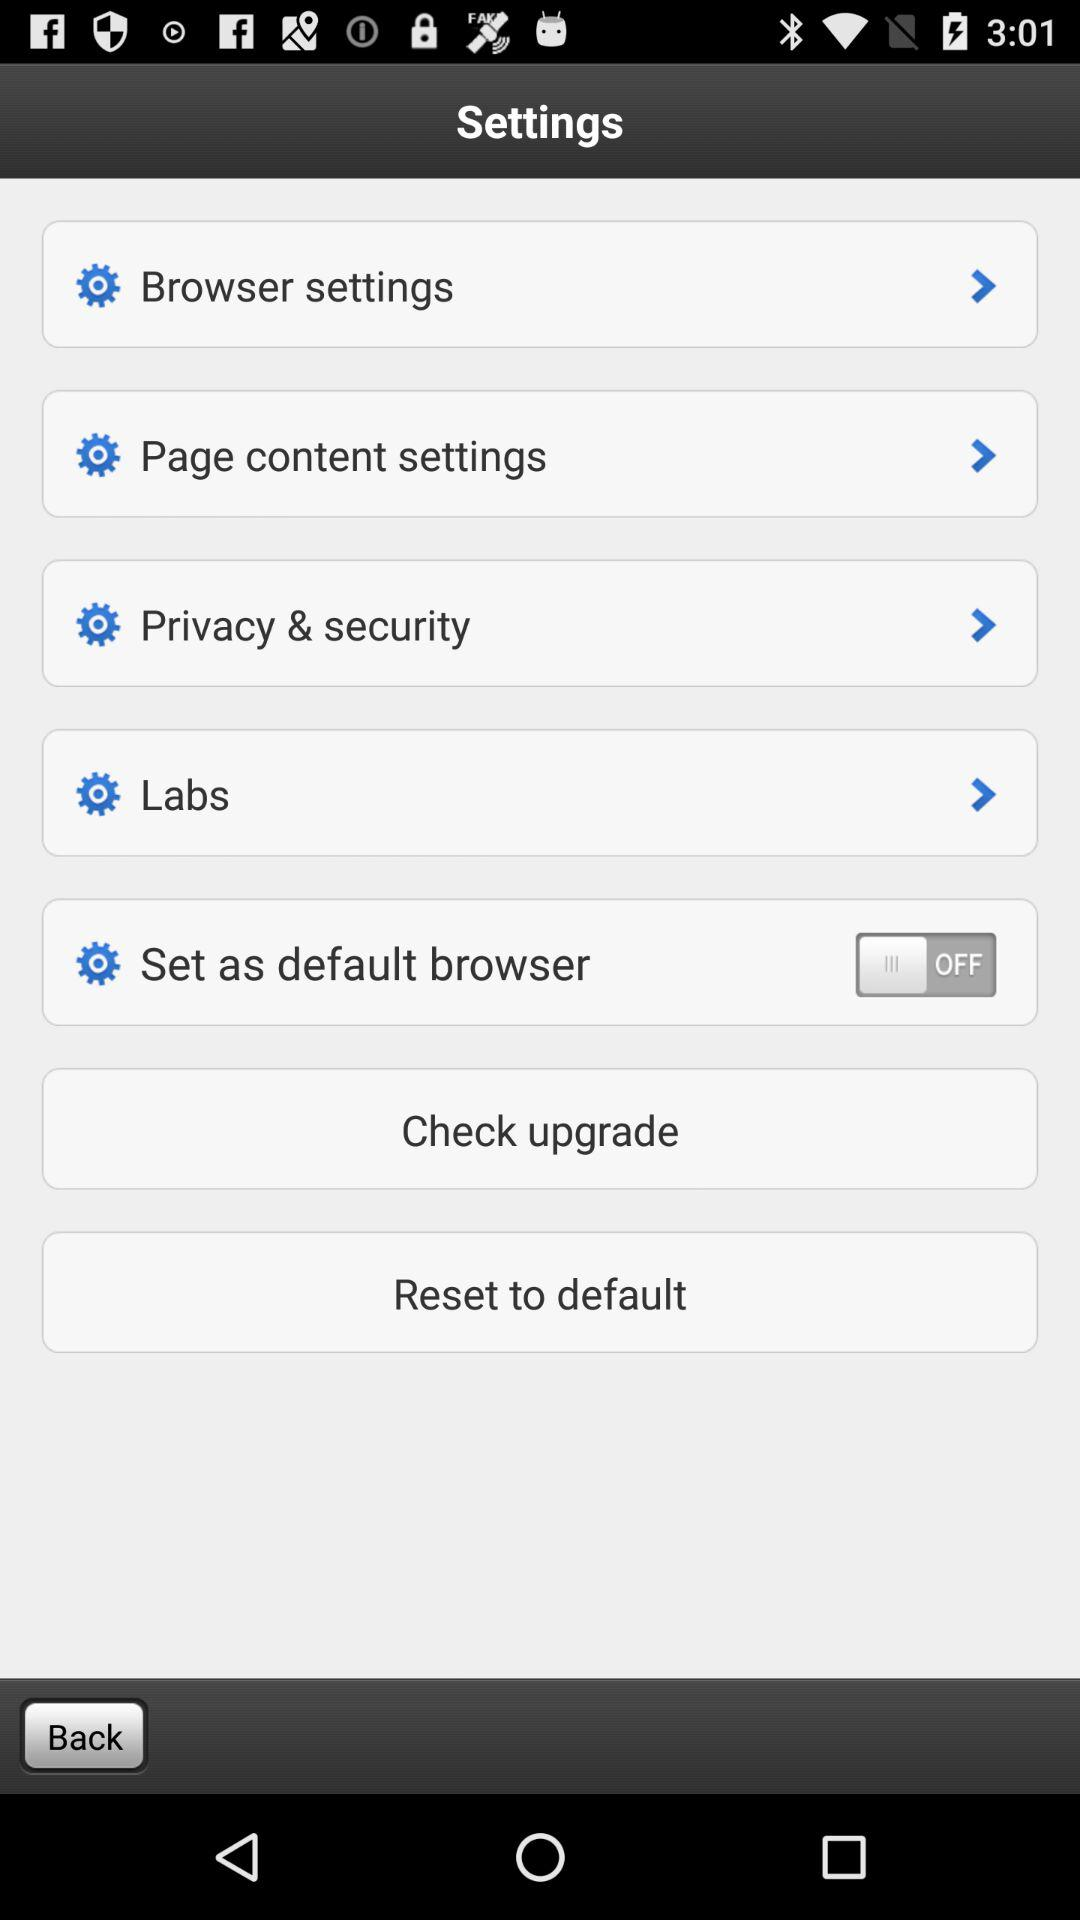What is the status of "Set as default browser"? "Set as default browser" is turned off. 